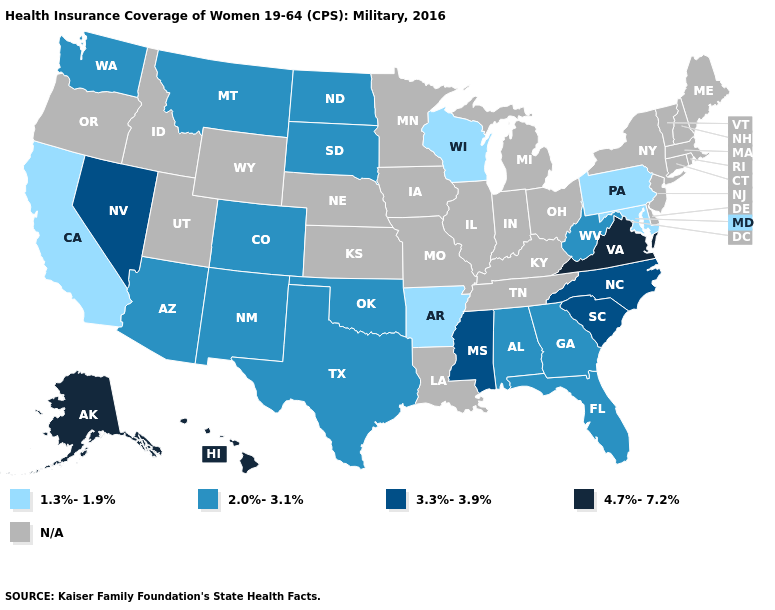What is the value of Texas?
Short answer required. 2.0%-3.1%. Which states have the lowest value in the West?
Keep it brief. California. Which states hav the highest value in the Northeast?
Answer briefly. Pennsylvania. Which states have the lowest value in the West?
Quick response, please. California. Among the states that border California , does Arizona have the highest value?
Give a very brief answer. No. Which states have the lowest value in the USA?
Be succinct. Arkansas, California, Maryland, Pennsylvania, Wisconsin. Name the states that have a value in the range 2.0%-3.1%?
Keep it brief. Alabama, Arizona, Colorado, Florida, Georgia, Montana, New Mexico, North Dakota, Oklahoma, South Dakota, Texas, Washington, West Virginia. Among the states that border Arizona , which have the highest value?
Give a very brief answer. Nevada. Name the states that have a value in the range 2.0%-3.1%?
Short answer required. Alabama, Arizona, Colorado, Florida, Georgia, Montana, New Mexico, North Dakota, Oklahoma, South Dakota, Texas, Washington, West Virginia. Name the states that have a value in the range 2.0%-3.1%?
Keep it brief. Alabama, Arizona, Colorado, Florida, Georgia, Montana, New Mexico, North Dakota, Oklahoma, South Dakota, Texas, Washington, West Virginia. What is the value of Indiana?
Be succinct. N/A. What is the value of North Dakota?
Write a very short answer. 2.0%-3.1%. What is the value of California?
Be succinct. 1.3%-1.9%. Name the states that have a value in the range N/A?
Be succinct. Connecticut, Delaware, Idaho, Illinois, Indiana, Iowa, Kansas, Kentucky, Louisiana, Maine, Massachusetts, Michigan, Minnesota, Missouri, Nebraska, New Hampshire, New Jersey, New York, Ohio, Oregon, Rhode Island, Tennessee, Utah, Vermont, Wyoming. What is the highest value in the USA?
Keep it brief. 4.7%-7.2%. 